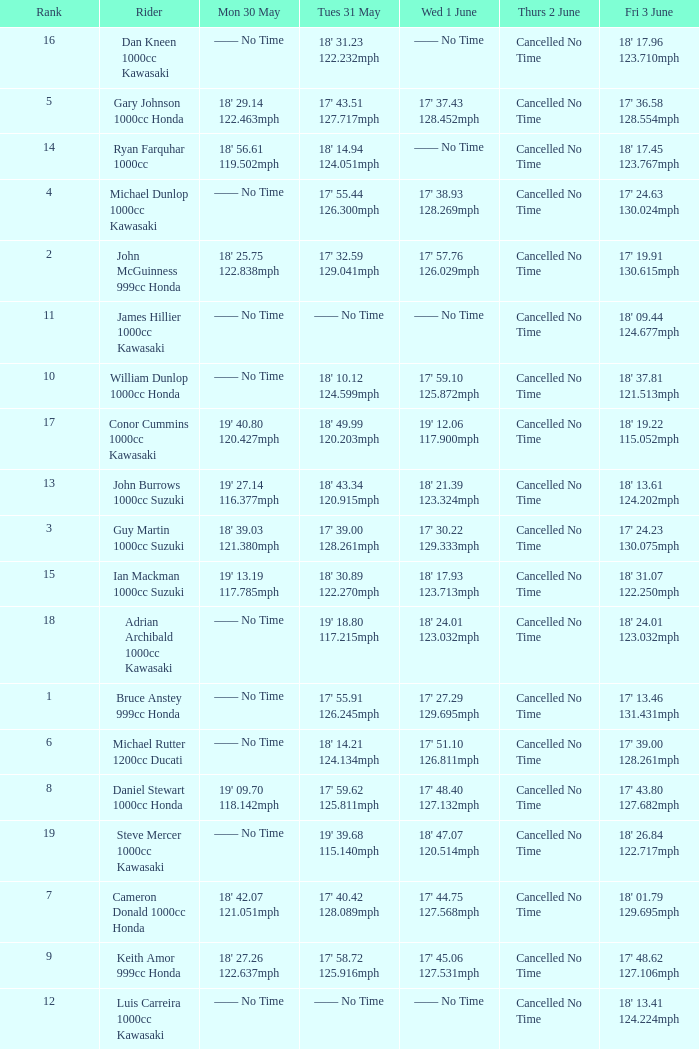What is the Fri 3 June time for the rider whose Tues 31 May time was 19' 18.80 117.215mph? 18' 24.01 123.032mph. Can you give me this table as a dict? {'header': ['Rank', 'Rider', 'Mon 30 May', 'Tues 31 May', 'Wed 1 June', 'Thurs 2 June', 'Fri 3 June'], 'rows': [['16', 'Dan Kneen 1000cc Kawasaki', '—— No Time', "18' 31.23 122.232mph", '—— No Time', 'Cancelled No Time', "18' 17.96 123.710mph"], ['5', 'Gary Johnson 1000cc Honda', "18' 29.14 122.463mph", "17' 43.51 127.717mph", "17' 37.43 128.452mph", 'Cancelled No Time', "17' 36.58 128.554mph"], ['14', 'Ryan Farquhar 1000cc', "18' 56.61 119.502mph", "18' 14.94 124.051mph", '—— No Time', 'Cancelled No Time', "18' 17.45 123.767mph"], ['4', 'Michael Dunlop 1000cc Kawasaki', '—— No Time', "17' 55.44 126.300mph", "17' 38.93 128.269mph", 'Cancelled No Time', "17' 24.63 130.024mph"], ['2', 'John McGuinness 999cc Honda', "18' 25.75 122.838mph", "17' 32.59 129.041mph", "17' 57.76 126.029mph", 'Cancelled No Time', "17' 19.91 130.615mph"], ['11', 'James Hillier 1000cc Kawasaki', '—— No Time', '—— No Time', '—— No Time', 'Cancelled No Time', "18' 09.44 124.677mph"], ['10', 'William Dunlop 1000cc Honda', '—— No Time', "18' 10.12 124.599mph", "17' 59.10 125.872mph", 'Cancelled No Time', "18' 37.81 121.513mph"], ['17', 'Conor Cummins 1000cc Kawasaki', "19' 40.80 120.427mph", "18' 49.99 120.203mph", "19' 12.06 117.900mph", 'Cancelled No Time', "18' 19.22 115.052mph"], ['13', 'John Burrows 1000cc Suzuki', "19' 27.14 116.377mph", "18' 43.34 120.915mph", "18' 21.39 123.324mph", 'Cancelled No Time', "18' 13.61 124.202mph"], ['3', 'Guy Martin 1000cc Suzuki', "18' 39.03 121.380mph", "17' 39.00 128.261mph", "17' 30.22 129.333mph", 'Cancelled No Time', "17' 24.23 130.075mph"], ['15', 'Ian Mackman 1000cc Suzuki', "19' 13.19 117.785mph", "18' 30.89 122.270mph", "18' 17.93 123.713mph", 'Cancelled No Time', "18' 31.07 122.250mph"], ['18', 'Adrian Archibald 1000cc Kawasaki', '—— No Time', "19' 18.80 117.215mph", "18' 24.01 123.032mph", 'Cancelled No Time', "18' 24.01 123.032mph"], ['1', 'Bruce Anstey 999cc Honda', '—— No Time', "17' 55.91 126.245mph", "17' 27.29 129.695mph", 'Cancelled No Time', "17' 13.46 131.431mph"], ['6', 'Michael Rutter 1200cc Ducati', '—— No Time', "18' 14.21 124.134mph", "17' 51.10 126.811mph", 'Cancelled No Time', "17' 39.00 128.261mph"], ['8', 'Daniel Stewart 1000cc Honda', "19' 09.70 118.142mph", "17' 59.62 125.811mph", "17' 48.40 127.132mph", 'Cancelled No Time', "17' 43.80 127.682mph"], ['19', 'Steve Mercer 1000cc Kawasaki', '—— No Time', "19' 39.68 115.140mph", "18' 47.07 120.514mph", 'Cancelled No Time', "18' 26.84 122.717mph"], ['7', 'Cameron Donald 1000cc Honda', "18' 42.07 121.051mph", "17' 40.42 128.089mph", "17' 44.75 127.568mph", 'Cancelled No Time', "18' 01.79 129.695mph"], ['9', 'Keith Amor 999cc Honda', "18' 27.26 122.637mph", "17' 58.72 125.916mph", "17' 45.06 127.531mph", 'Cancelled No Time', "17' 48.62 127.106mph"], ['12', 'Luis Carreira 1000cc Kawasaki', '—— No Time', '—— No Time', '—— No Time', 'Cancelled No Time', "18' 13.41 124.224mph"]]} 